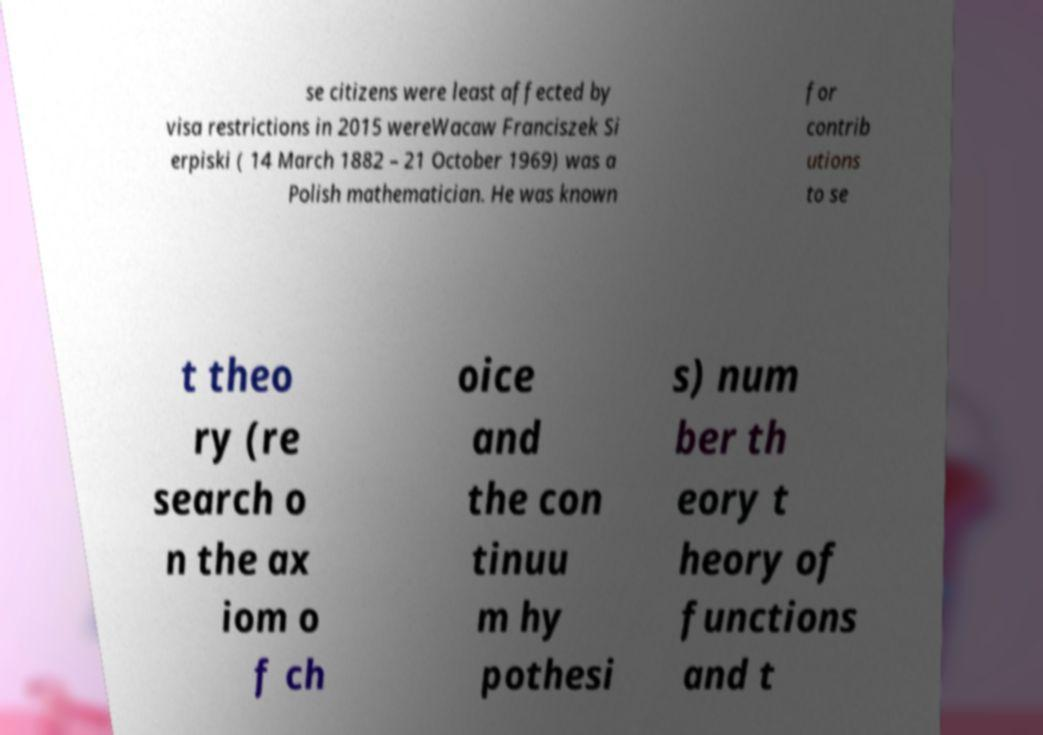Please read and relay the text visible in this image. What does it say? se citizens were least affected by visa restrictions in 2015 wereWacaw Franciszek Si erpiski ( 14 March 1882 – 21 October 1969) was a Polish mathematician. He was known for contrib utions to se t theo ry (re search o n the ax iom o f ch oice and the con tinuu m hy pothesi s) num ber th eory t heory of functions and t 